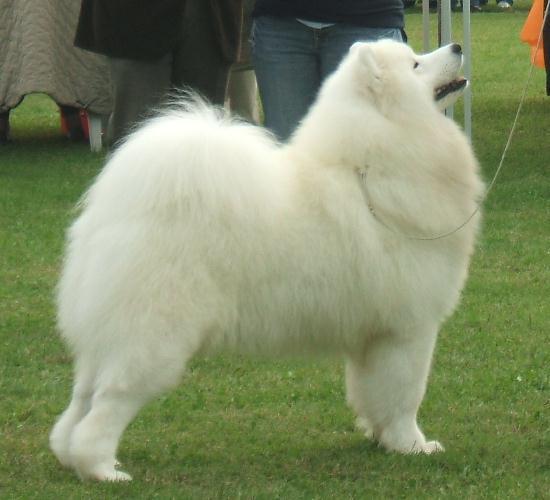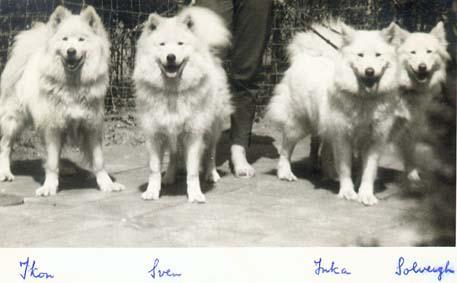The first image is the image on the left, the second image is the image on the right. Given the left and right images, does the statement "Each image contains exactly one fluffy dog." hold true? Answer yes or no. No. The first image is the image on the left, the second image is the image on the right. Assess this claim about the two images: "Both images contain a single dog.". Correct or not? Answer yes or no. No. 